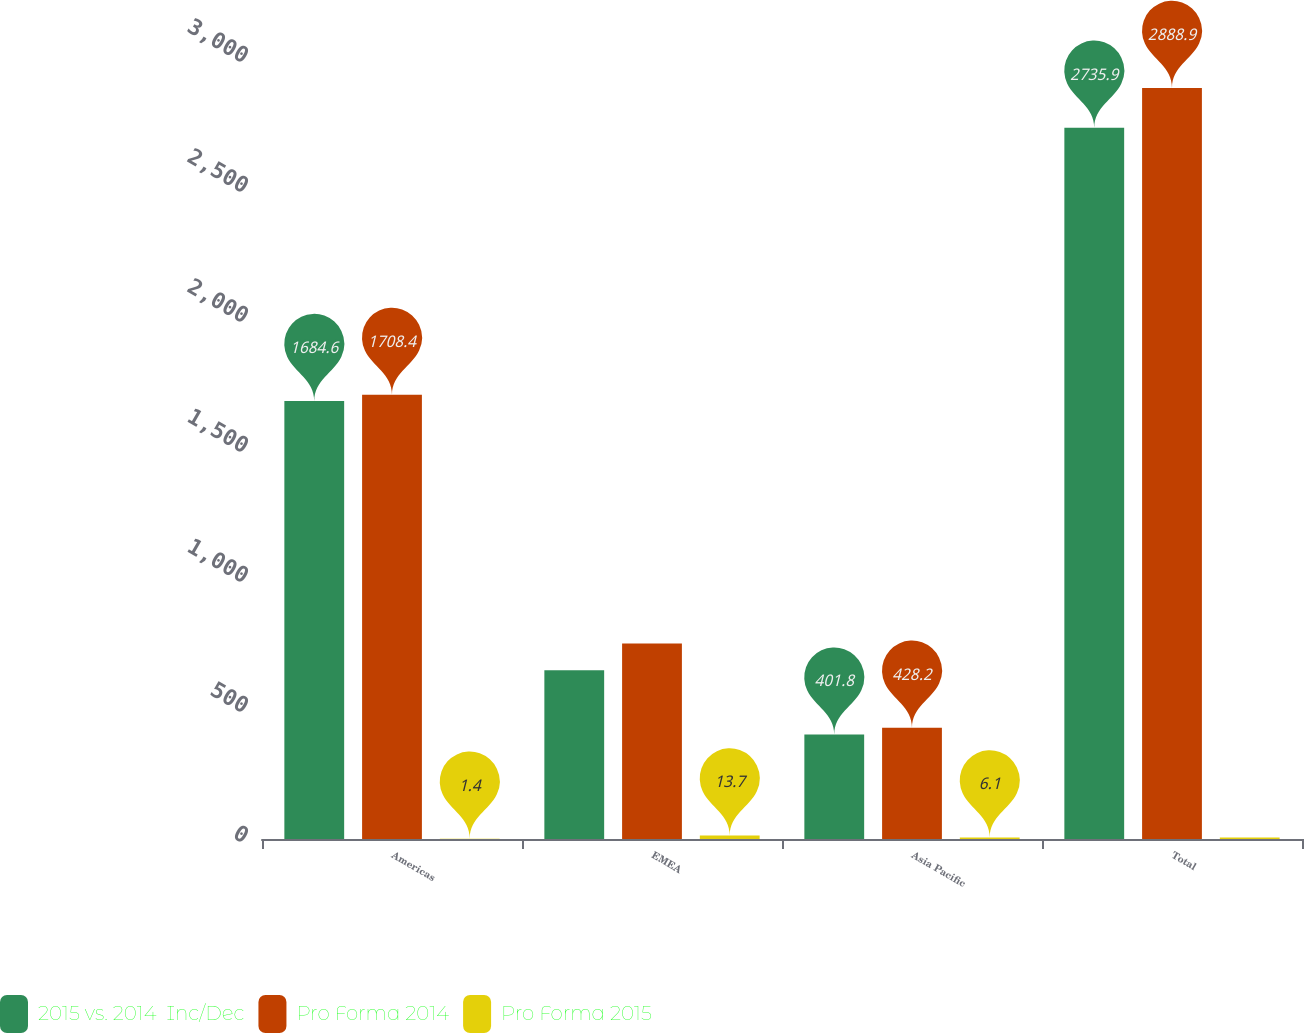Convert chart to OTSL. <chart><loc_0><loc_0><loc_500><loc_500><stacked_bar_chart><ecel><fcel>Americas<fcel>EMEA<fcel>Asia Pacific<fcel>Total<nl><fcel>2015 vs. 2014  Inc/Dec<fcel>1684.6<fcel>649.5<fcel>401.8<fcel>2735.9<nl><fcel>Pro Forma 2014<fcel>1708.4<fcel>752.3<fcel>428.2<fcel>2888.9<nl><fcel>Pro Forma 2015<fcel>1.4<fcel>13.7<fcel>6.1<fcel>5.3<nl></chart> 